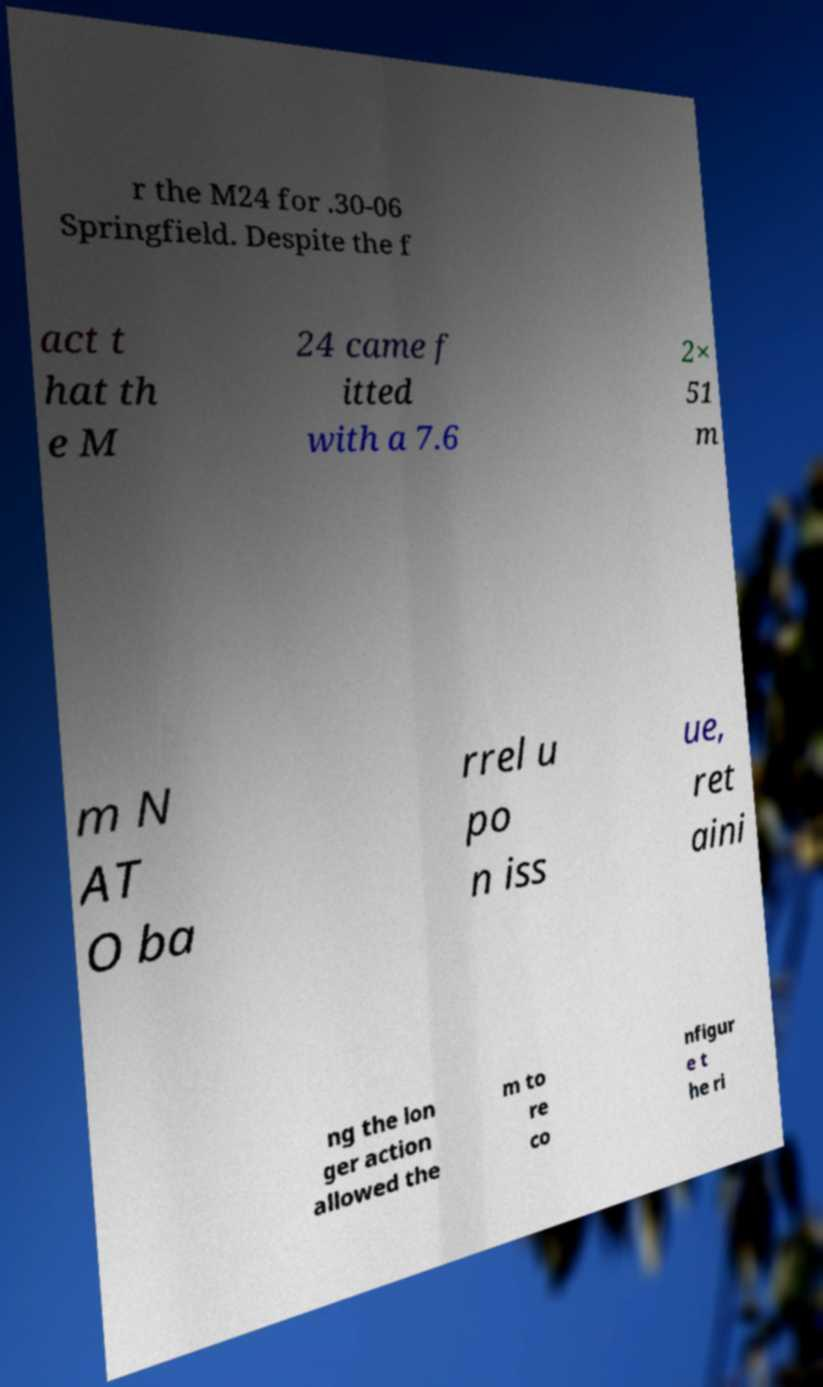Could you extract and type out the text from this image? r the M24 for .30-06 Springfield. Despite the f act t hat th e M 24 came f itted with a 7.6 2× 51 m m N AT O ba rrel u po n iss ue, ret aini ng the lon ger action allowed the m to re co nfigur e t he ri 